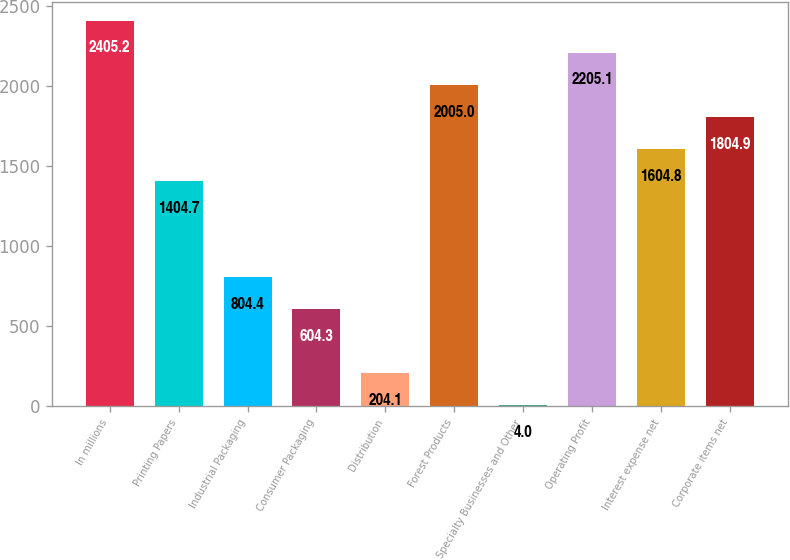Convert chart. <chart><loc_0><loc_0><loc_500><loc_500><bar_chart><fcel>In millions<fcel>Printing Papers<fcel>Industrial Packaging<fcel>Consumer Packaging<fcel>Distribution<fcel>Forest Products<fcel>Specialty Businesses and Other<fcel>Operating Profit<fcel>Interest expense net<fcel>Corporate items net<nl><fcel>2405.2<fcel>1404.7<fcel>804.4<fcel>604.3<fcel>204.1<fcel>2005<fcel>4<fcel>2205.1<fcel>1604.8<fcel>1804.9<nl></chart> 